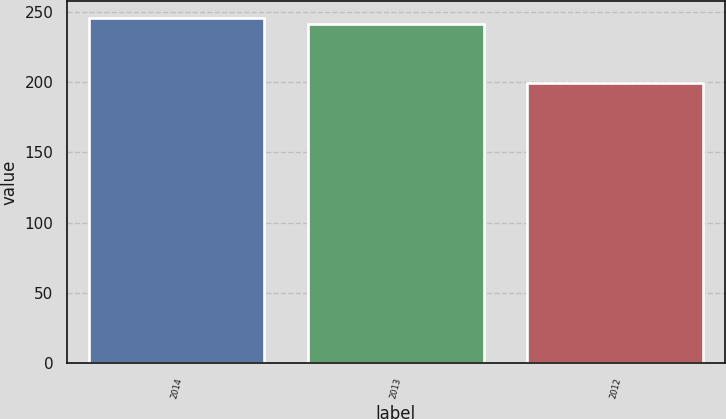<chart> <loc_0><loc_0><loc_500><loc_500><bar_chart><fcel>2014<fcel>2013<fcel>2012<nl><fcel>245.5<fcel>241<fcel>199<nl></chart> 